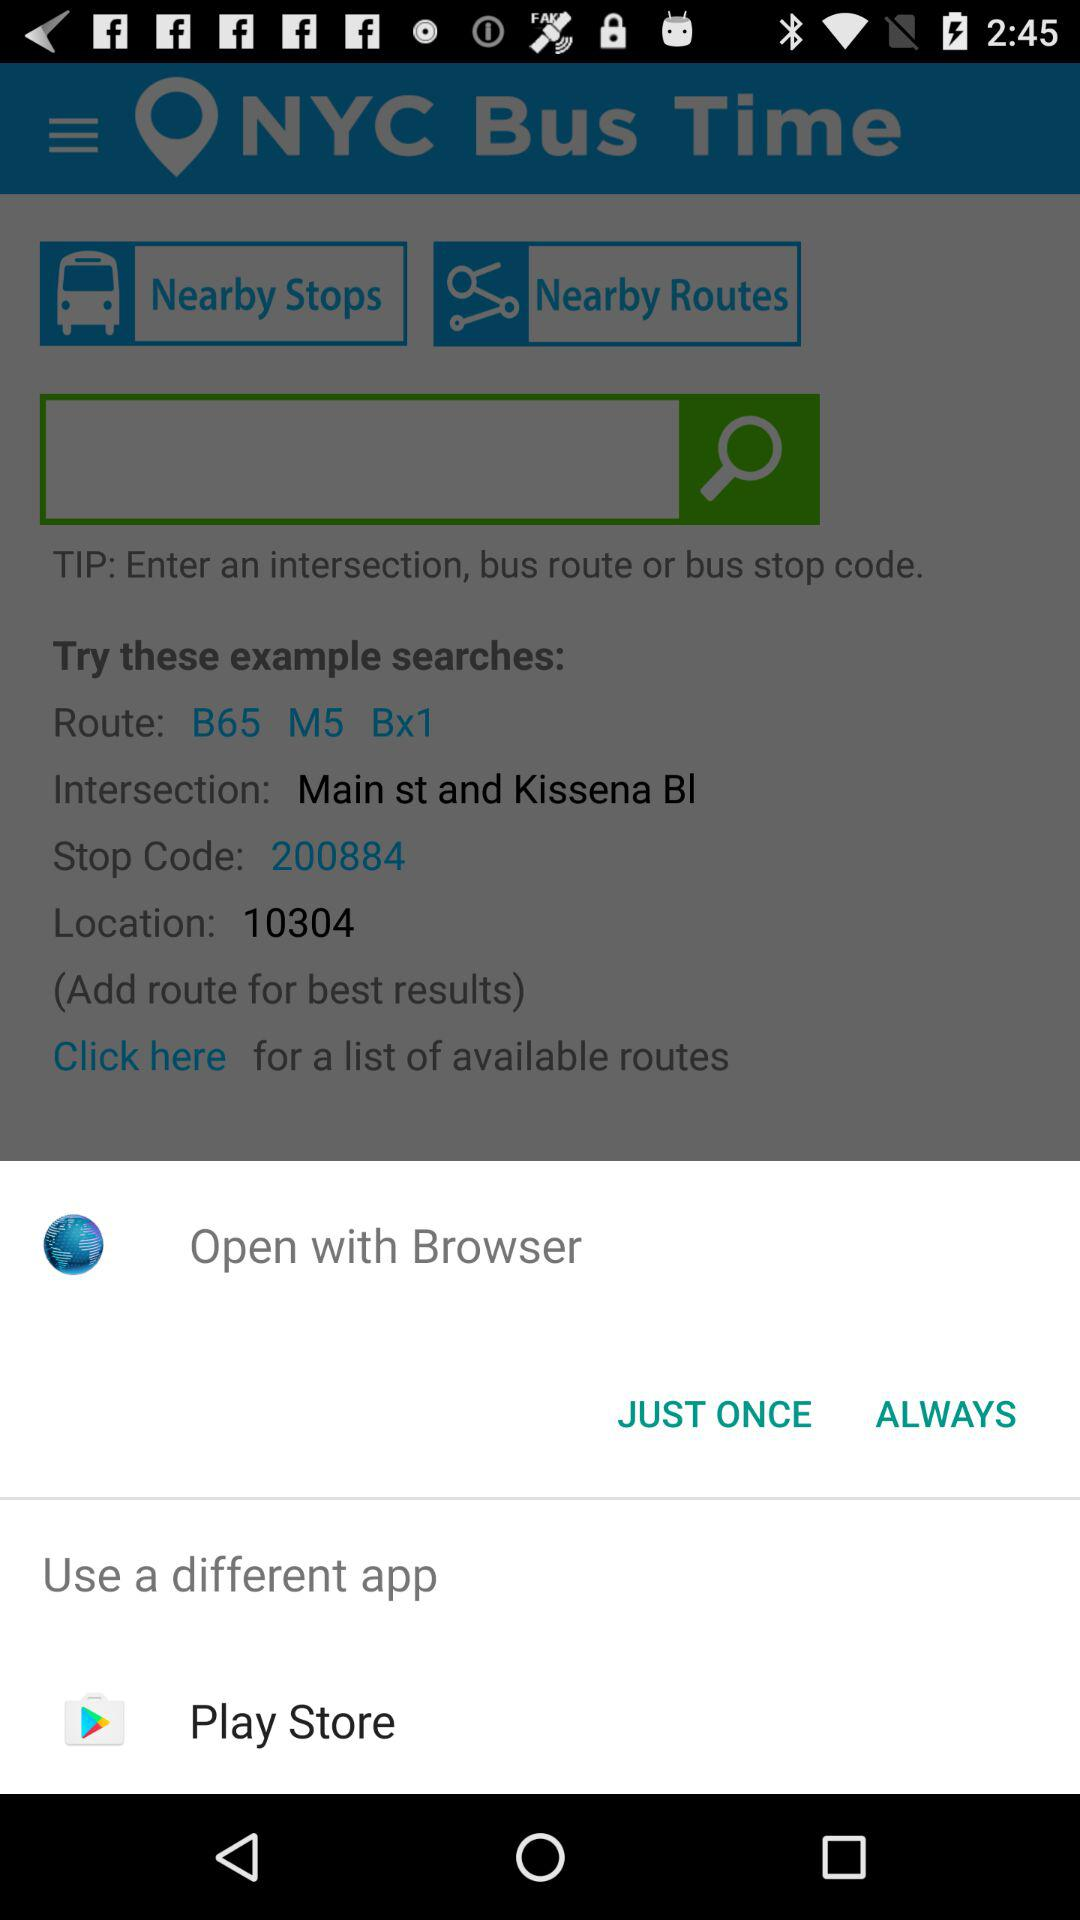Which application is selected to open the content?
When the provided information is insufficient, respond with <no answer>. <no answer> 